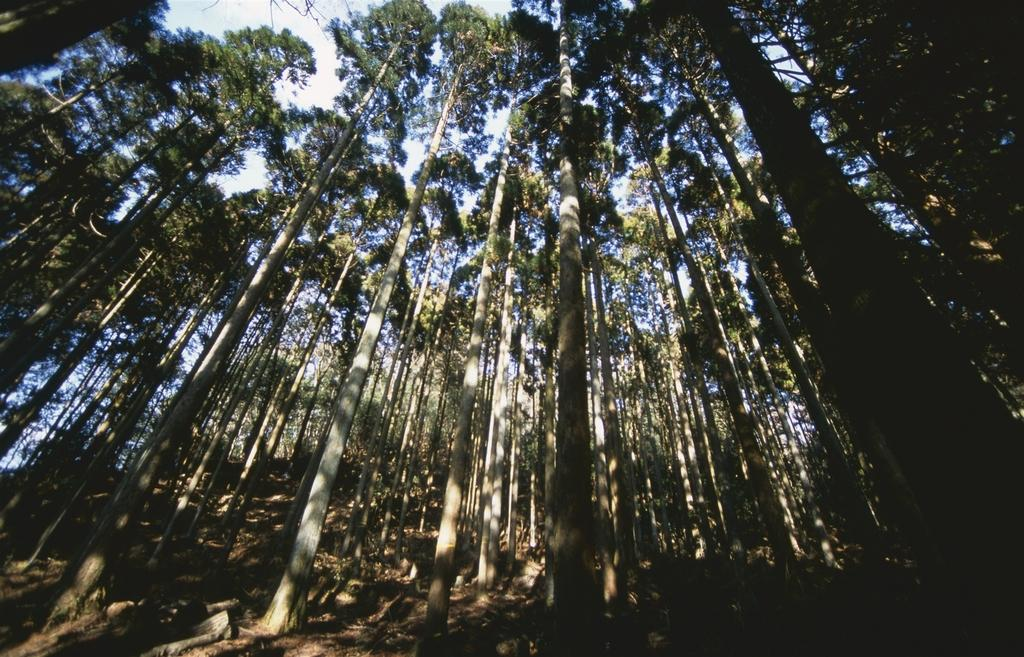What type of vegetation can be seen in the image? There are trees in the image. What part of the natural environment is visible in the background of the image? The sky is visible in the background of the image. What arithmetic problem is being solved by the trees in the image? There is no arithmetic problem being solved by the trees in the image, as trees are living organisms and do not perform arithmetic. 